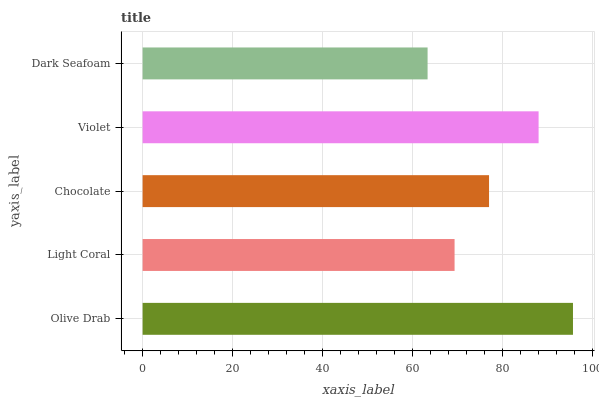Is Dark Seafoam the minimum?
Answer yes or no. Yes. Is Olive Drab the maximum?
Answer yes or no. Yes. Is Light Coral the minimum?
Answer yes or no. No. Is Light Coral the maximum?
Answer yes or no. No. Is Olive Drab greater than Light Coral?
Answer yes or no. Yes. Is Light Coral less than Olive Drab?
Answer yes or no. Yes. Is Light Coral greater than Olive Drab?
Answer yes or no. No. Is Olive Drab less than Light Coral?
Answer yes or no. No. Is Chocolate the high median?
Answer yes or no. Yes. Is Chocolate the low median?
Answer yes or no. Yes. Is Light Coral the high median?
Answer yes or no. No. Is Violet the low median?
Answer yes or no. No. 